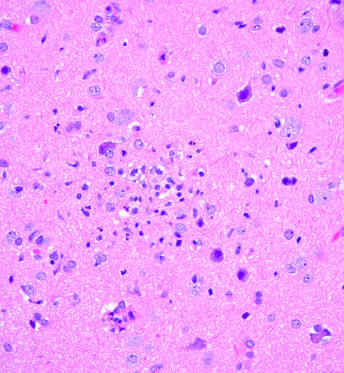what did the collection of microglial cells form?
Answer the question using a single word or phrase. A poorly defined nodule 